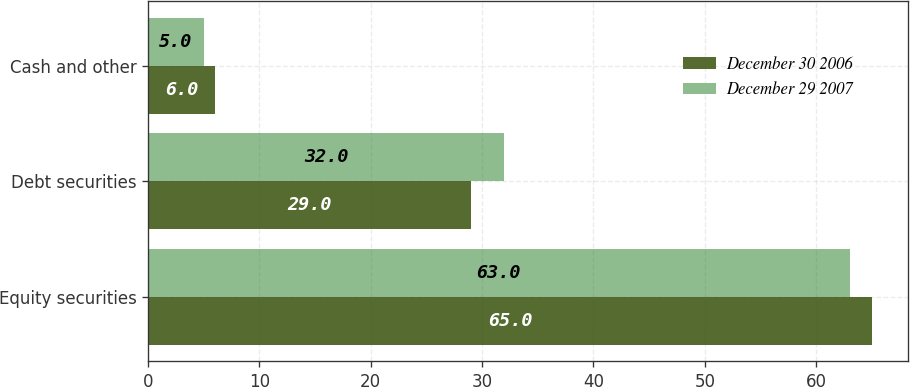Convert chart to OTSL. <chart><loc_0><loc_0><loc_500><loc_500><stacked_bar_chart><ecel><fcel>Equity securities<fcel>Debt securities<fcel>Cash and other<nl><fcel>December 30 2006<fcel>65<fcel>29<fcel>6<nl><fcel>December 29 2007<fcel>63<fcel>32<fcel>5<nl></chart> 